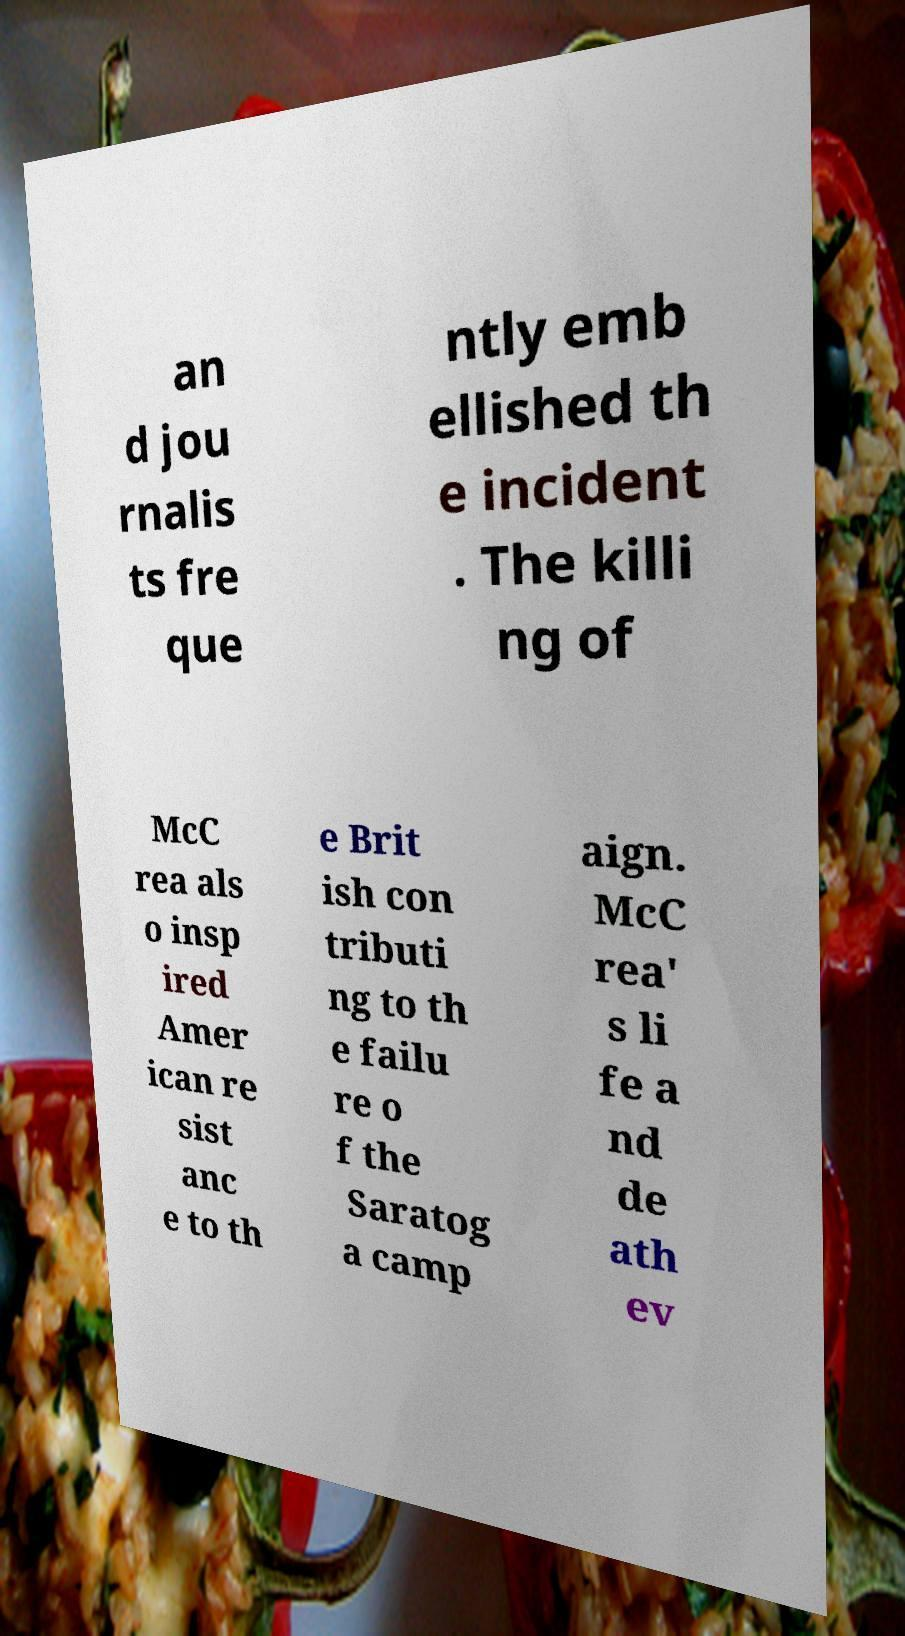Can you accurately transcribe the text from the provided image for me? an d jou rnalis ts fre que ntly emb ellished th e incident . The killi ng of McC rea als o insp ired Amer ican re sist anc e to th e Brit ish con tributi ng to th e failu re o f the Saratog a camp aign. McC rea' s li fe a nd de ath ev 